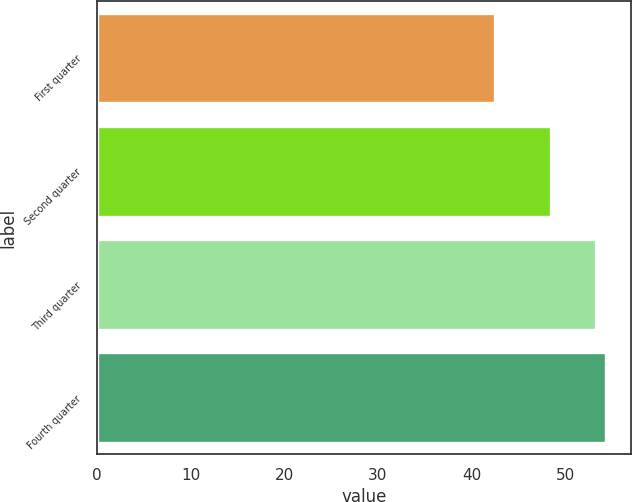Convert chart. <chart><loc_0><loc_0><loc_500><loc_500><bar_chart><fcel>First quarter<fcel>Second quarter<fcel>Third quarter<fcel>Fourth quarter<nl><fcel>42.53<fcel>48.47<fcel>53.2<fcel>54.31<nl></chart> 